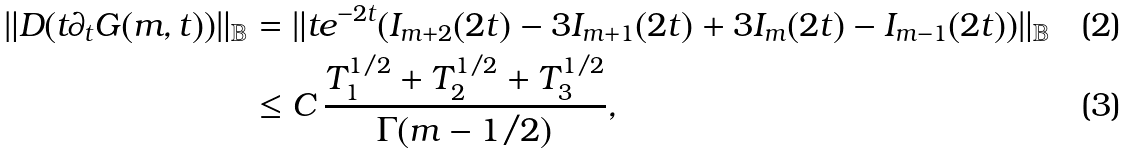Convert formula to latex. <formula><loc_0><loc_0><loc_500><loc_500>\| D ( t \partial _ { t } G ( m , t ) ) \| _ { \mathbb { B } } & = \| t e ^ { - 2 t } ( I _ { m + 2 } ( 2 t ) - 3 I _ { m + 1 } ( 2 t ) + 3 I _ { m } ( 2 t ) - I _ { m - 1 } ( 2 t ) ) \| _ { \mathbb { B } } \\ & \leq C \, \frac { T _ { 1 } ^ { 1 / 2 } + T _ { 2 } ^ { 1 / 2 } + T _ { 3 } ^ { 1 / 2 } } { \Gamma ( m - 1 / 2 ) } ,</formula> 